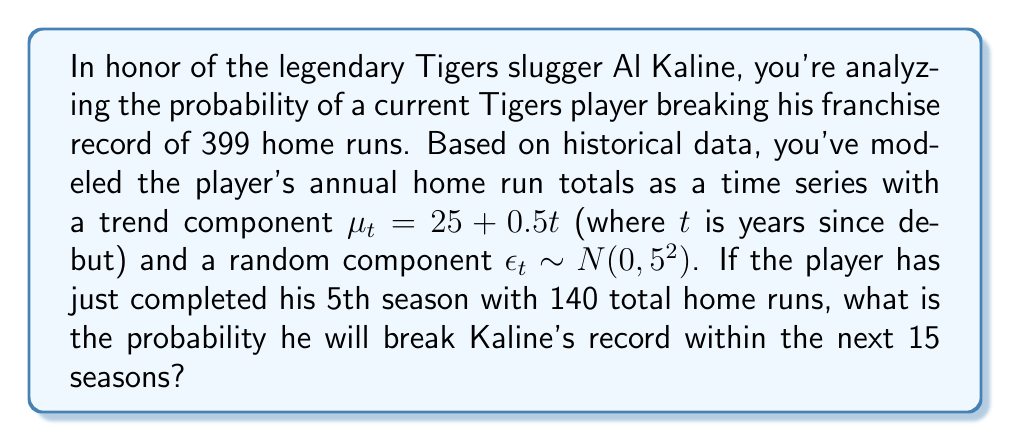Show me your answer to this math problem. Let's approach this step-by-step:

1) First, we need to calculate how many more home runs the player needs to hit to break the record:
   399 - 140 = 259 home runs

2) Now, we need to model the total number of home runs over the next 15 seasons. Let's call this random variable $X$. It will be the sum of 15 annual totals, each following the model:

   $HR_t = \mu_t + \epsilon_t = (25 + 0.5t) + \epsilon_t$

3) The mean of $X$ will be the sum of the trend components:

   $E[X] = \sum_{t=6}^{20} (25 + 0.5t) = 15 * 25 + 0.5 * \sum_{t=6}^{20} t$

   $= 375 + 0.5 * (20*21/2 - 5*6/2) = 375 + 0.5 * 195 = 472.5$

4) The variance of $X$ will be the sum of the variances of the random components:

   $Var(X) = 15 * 5^2 = 375$

5) Therefore, $X \sim N(472.5, \sqrt{375})$

6) We want to find $P(X > 259)$. We can standardize this:

   $Z = \frac{X - 472.5}{\sqrt{375}} \sim N(0,1)$

   $P(X > 259) = P(Z > \frac{259 - 472.5}{\sqrt{375}}) = P(Z > -11.01)$

7) Using a standard normal table or calculator, we can find this probability:

   $P(Z > -11.01) \approx 1$
Answer: The probability is approximately 1 or 100%. 